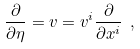<formula> <loc_0><loc_0><loc_500><loc_500>\frac { \partial } { \partial \eta } = v = v ^ { i } \frac { \partial } { \partial x ^ { i } } \ ,</formula> 